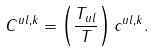<formula> <loc_0><loc_0><loc_500><loc_500>C ^ { u l , k } = \left ( \frac { T _ { u l } } { T } \right ) c ^ { u l , k } .</formula> 